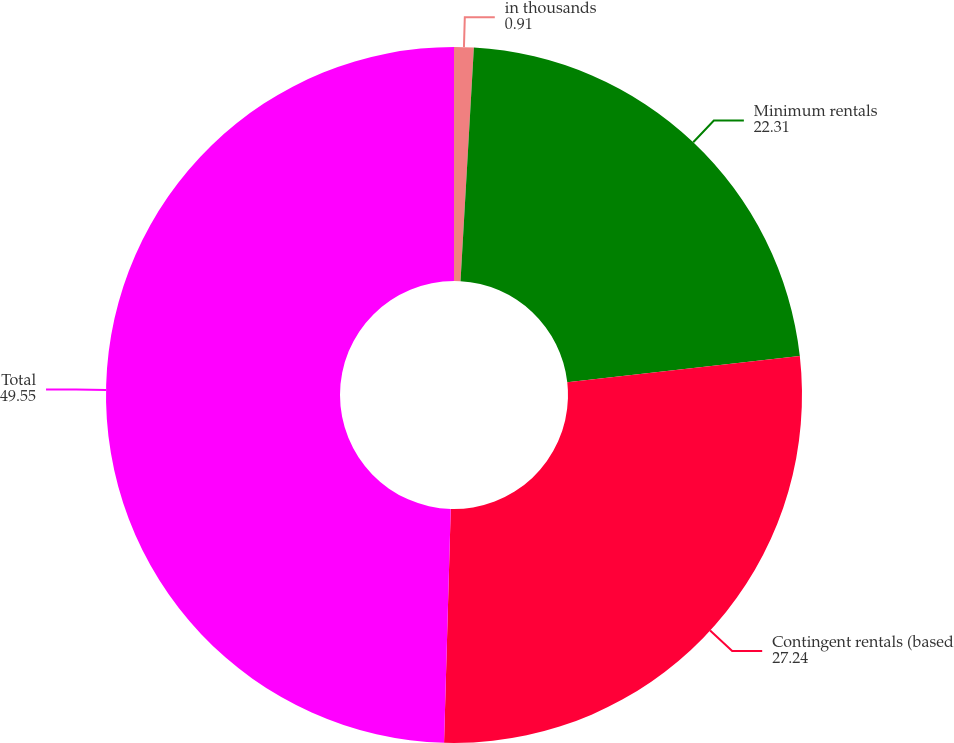<chart> <loc_0><loc_0><loc_500><loc_500><pie_chart><fcel>in thousands<fcel>Minimum rentals<fcel>Contingent rentals (based<fcel>Total<nl><fcel>0.91%<fcel>22.31%<fcel>27.24%<fcel>49.55%<nl></chart> 